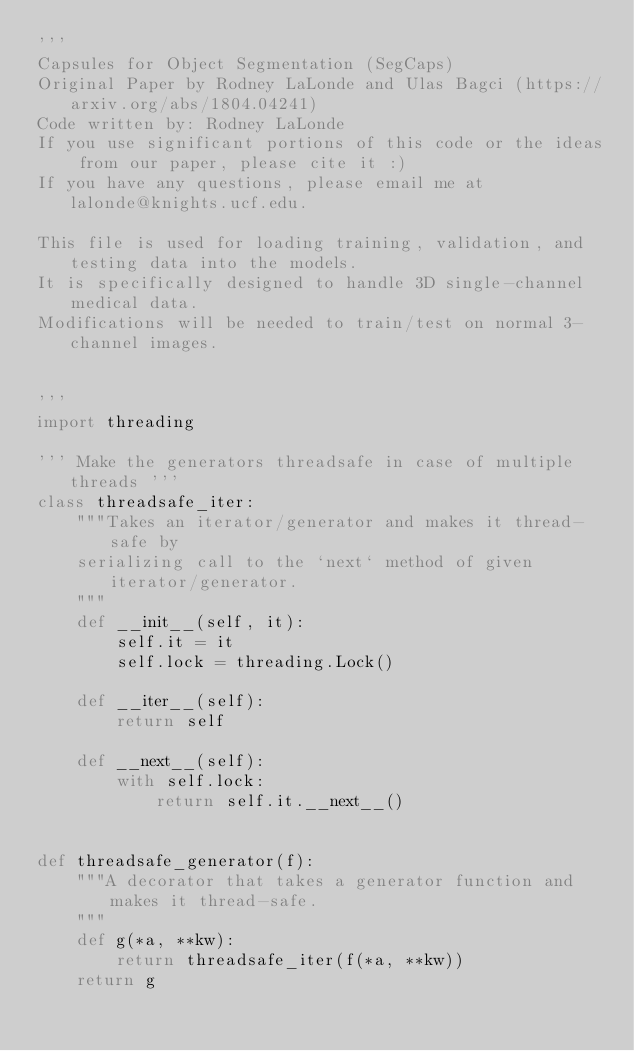<code> <loc_0><loc_0><loc_500><loc_500><_Python_>'''
Capsules for Object Segmentation (SegCaps)
Original Paper by Rodney LaLonde and Ulas Bagci (https://arxiv.org/abs/1804.04241)
Code written by: Rodney LaLonde
If you use significant portions of this code or the ideas from our paper, please cite it :)
If you have any questions, please email me at lalonde@knights.ucf.edu.

This file is used for loading training, validation, and testing data into the models.
It is specifically designed to handle 3D single-channel medical data.
Modifications will be needed to train/test on normal 3-channel images.


'''
import threading

''' Make the generators threadsafe in case of multiple threads '''
class threadsafe_iter:
    """Takes an iterator/generator and makes it thread-safe by
    serializing call to the `next` method of given iterator/generator.
    """
    def __init__(self, it):
        self.it = it
        self.lock = threading.Lock()

    def __iter__(self):
        return self

    def __next__(self):
        with self.lock:
            return self.it.__next__()


def threadsafe_generator(f):
    """A decorator that takes a generator function and makes it thread-safe.
    """
    def g(*a, **kw):
        return threadsafe_iter(f(*a, **kw))
    return g

</code> 